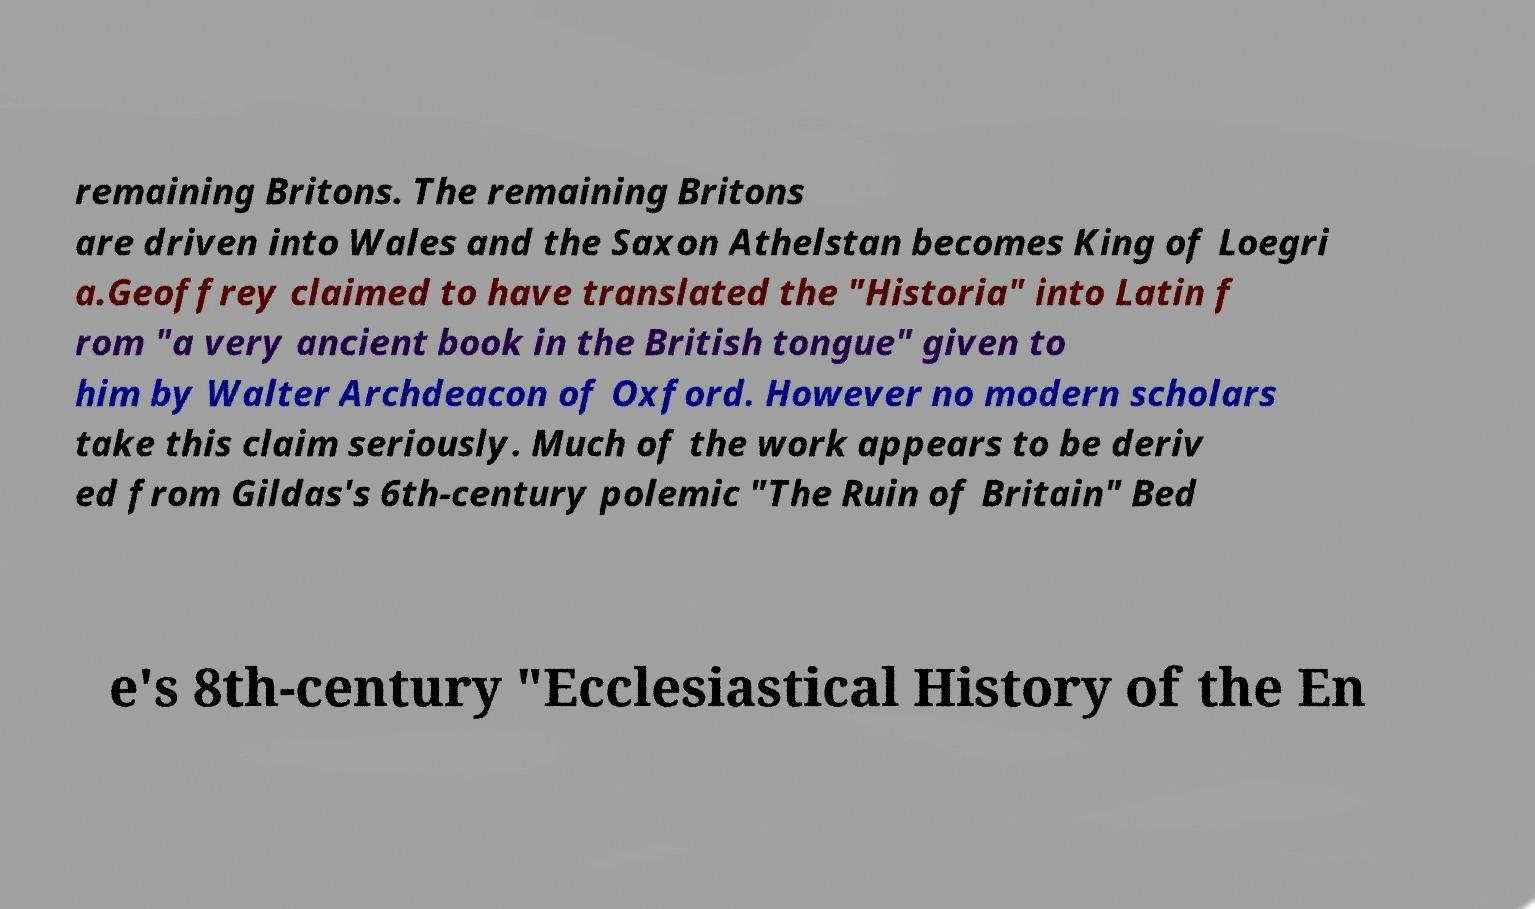Can you accurately transcribe the text from the provided image for me? remaining Britons. The remaining Britons are driven into Wales and the Saxon Athelstan becomes King of Loegri a.Geoffrey claimed to have translated the "Historia" into Latin f rom "a very ancient book in the British tongue" given to him by Walter Archdeacon of Oxford. However no modern scholars take this claim seriously. Much of the work appears to be deriv ed from Gildas's 6th-century polemic "The Ruin of Britain" Bed e's 8th-century "Ecclesiastical History of the En 